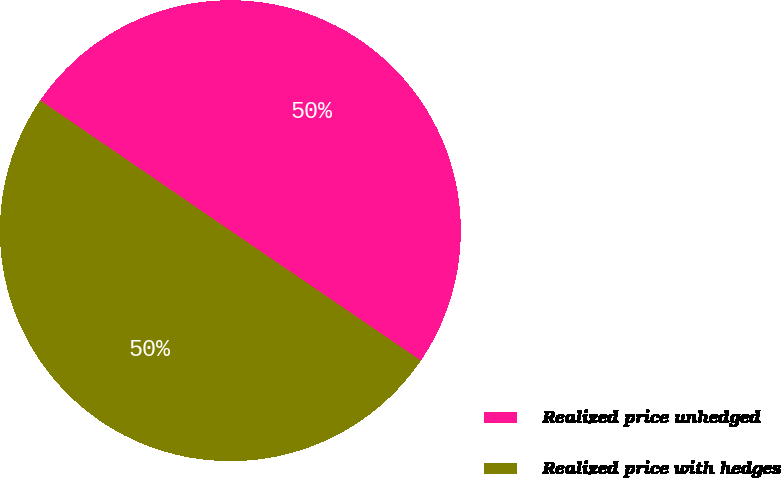Convert chart to OTSL. <chart><loc_0><loc_0><loc_500><loc_500><pie_chart><fcel>Realized price unhedged<fcel>Realized price with hedges<nl><fcel>49.97%<fcel>50.03%<nl></chart> 